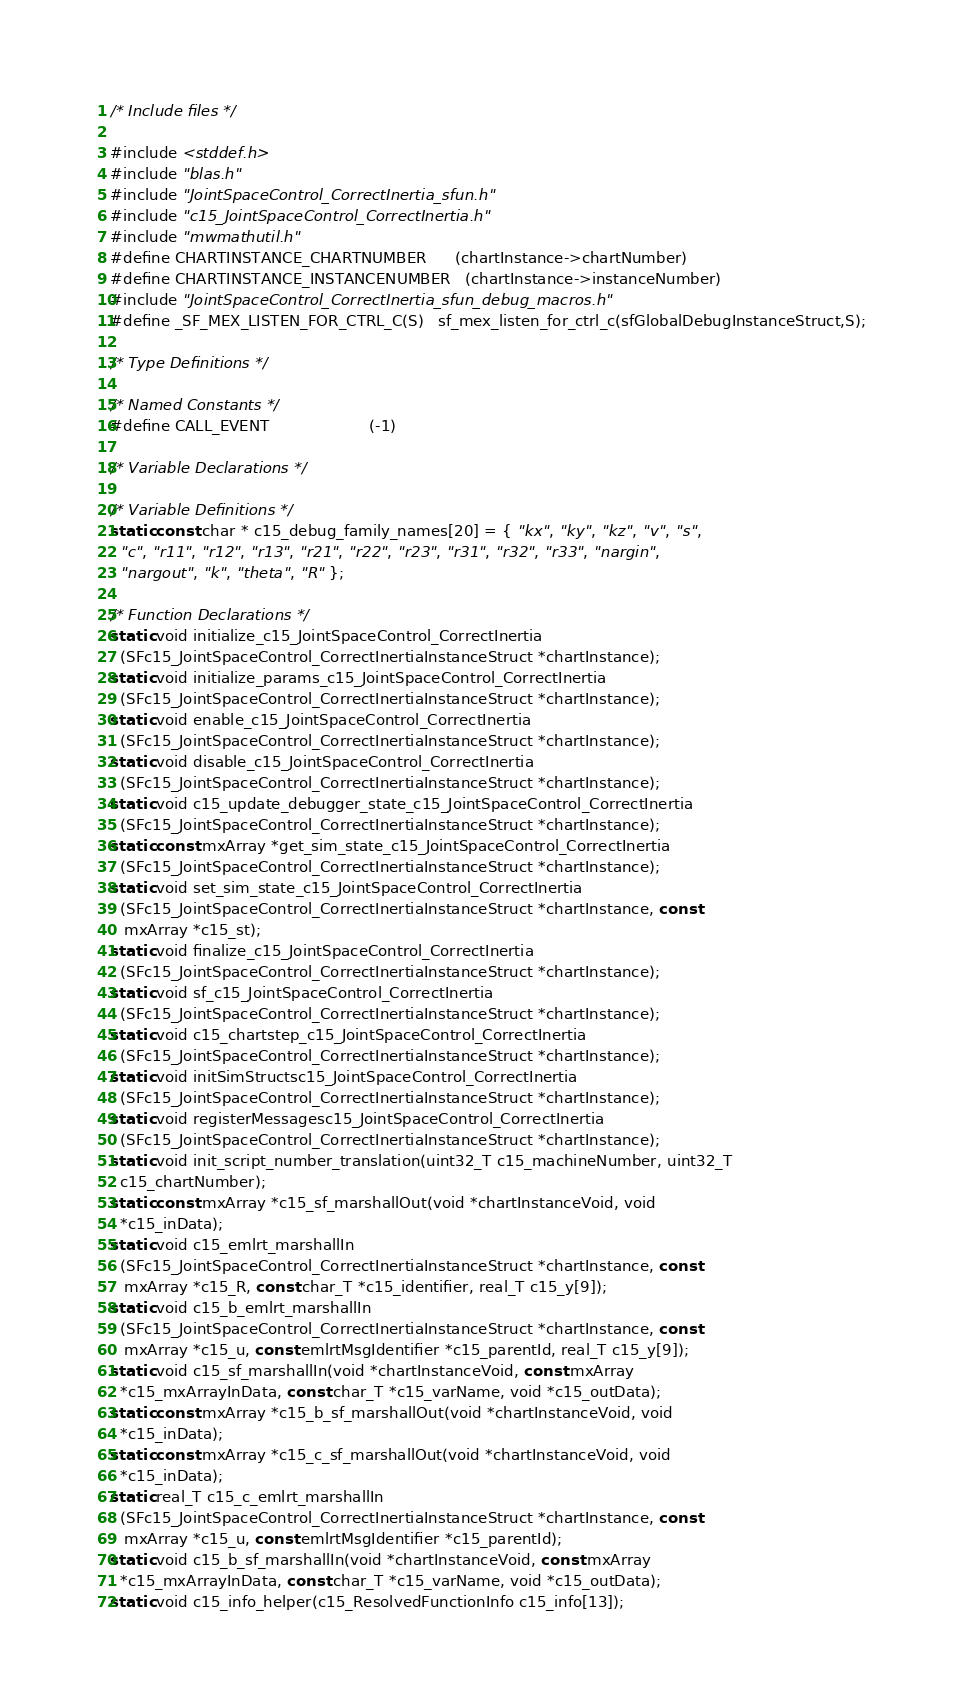<code> <loc_0><loc_0><loc_500><loc_500><_C_>/* Include files */

#include <stddef.h>
#include "blas.h"
#include "JointSpaceControl_CorrectInertia_sfun.h"
#include "c15_JointSpaceControl_CorrectInertia.h"
#include "mwmathutil.h"
#define CHARTINSTANCE_CHARTNUMBER      (chartInstance->chartNumber)
#define CHARTINSTANCE_INSTANCENUMBER   (chartInstance->instanceNumber)
#include "JointSpaceControl_CorrectInertia_sfun_debug_macros.h"
#define _SF_MEX_LISTEN_FOR_CTRL_C(S)   sf_mex_listen_for_ctrl_c(sfGlobalDebugInstanceStruct,S);

/* Type Definitions */

/* Named Constants */
#define CALL_EVENT                     (-1)

/* Variable Declarations */

/* Variable Definitions */
static const char * c15_debug_family_names[20] = { "kx", "ky", "kz", "v", "s",
  "c", "r11", "r12", "r13", "r21", "r22", "r23", "r31", "r32", "r33", "nargin",
  "nargout", "k", "theta", "R" };

/* Function Declarations */
static void initialize_c15_JointSpaceControl_CorrectInertia
  (SFc15_JointSpaceControl_CorrectInertiaInstanceStruct *chartInstance);
static void initialize_params_c15_JointSpaceControl_CorrectInertia
  (SFc15_JointSpaceControl_CorrectInertiaInstanceStruct *chartInstance);
static void enable_c15_JointSpaceControl_CorrectInertia
  (SFc15_JointSpaceControl_CorrectInertiaInstanceStruct *chartInstance);
static void disable_c15_JointSpaceControl_CorrectInertia
  (SFc15_JointSpaceControl_CorrectInertiaInstanceStruct *chartInstance);
static void c15_update_debugger_state_c15_JointSpaceControl_CorrectInertia
  (SFc15_JointSpaceControl_CorrectInertiaInstanceStruct *chartInstance);
static const mxArray *get_sim_state_c15_JointSpaceControl_CorrectInertia
  (SFc15_JointSpaceControl_CorrectInertiaInstanceStruct *chartInstance);
static void set_sim_state_c15_JointSpaceControl_CorrectInertia
  (SFc15_JointSpaceControl_CorrectInertiaInstanceStruct *chartInstance, const
   mxArray *c15_st);
static void finalize_c15_JointSpaceControl_CorrectInertia
  (SFc15_JointSpaceControl_CorrectInertiaInstanceStruct *chartInstance);
static void sf_c15_JointSpaceControl_CorrectInertia
  (SFc15_JointSpaceControl_CorrectInertiaInstanceStruct *chartInstance);
static void c15_chartstep_c15_JointSpaceControl_CorrectInertia
  (SFc15_JointSpaceControl_CorrectInertiaInstanceStruct *chartInstance);
static void initSimStructsc15_JointSpaceControl_CorrectInertia
  (SFc15_JointSpaceControl_CorrectInertiaInstanceStruct *chartInstance);
static void registerMessagesc15_JointSpaceControl_CorrectInertia
  (SFc15_JointSpaceControl_CorrectInertiaInstanceStruct *chartInstance);
static void init_script_number_translation(uint32_T c15_machineNumber, uint32_T
  c15_chartNumber);
static const mxArray *c15_sf_marshallOut(void *chartInstanceVoid, void
  *c15_inData);
static void c15_emlrt_marshallIn
  (SFc15_JointSpaceControl_CorrectInertiaInstanceStruct *chartInstance, const
   mxArray *c15_R, const char_T *c15_identifier, real_T c15_y[9]);
static void c15_b_emlrt_marshallIn
  (SFc15_JointSpaceControl_CorrectInertiaInstanceStruct *chartInstance, const
   mxArray *c15_u, const emlrtMsgIdentifier *c15_parentId, real_T c15_y[9]);
static void c15_sf_marshallIn(void *chartInstanceVoid, const mxArray
  *c15_mxArrayInData, const char_T *c15_varName, void *c15_outData);
static const mxArray *c15_b_sf_marshallOut(void *chartInstanceVoid, void
  *c15_inData);
static const mxArray *c15_c_sf_marshallOut(void *chartInstanceVoid, void
  *c15_inData);
static real_T c15_c_emlrt_marshallIn
  (SFc15_JointSpaceControl_CorrectInertiaInstanceStruct *chartInstance, const
   mxArray *c15_u, const emlrtMsgIdentifier *c15_parentId);
static void c15_b_sf_marshallIn(void *chartInstanceVoid, const mxArray
  *c15_mxArrayInData, const char_T *c15_varName, void *c15_outData);
static void c15_info_helper(c15_ResolvedFunctionInfo c15_info[13]);</code> 